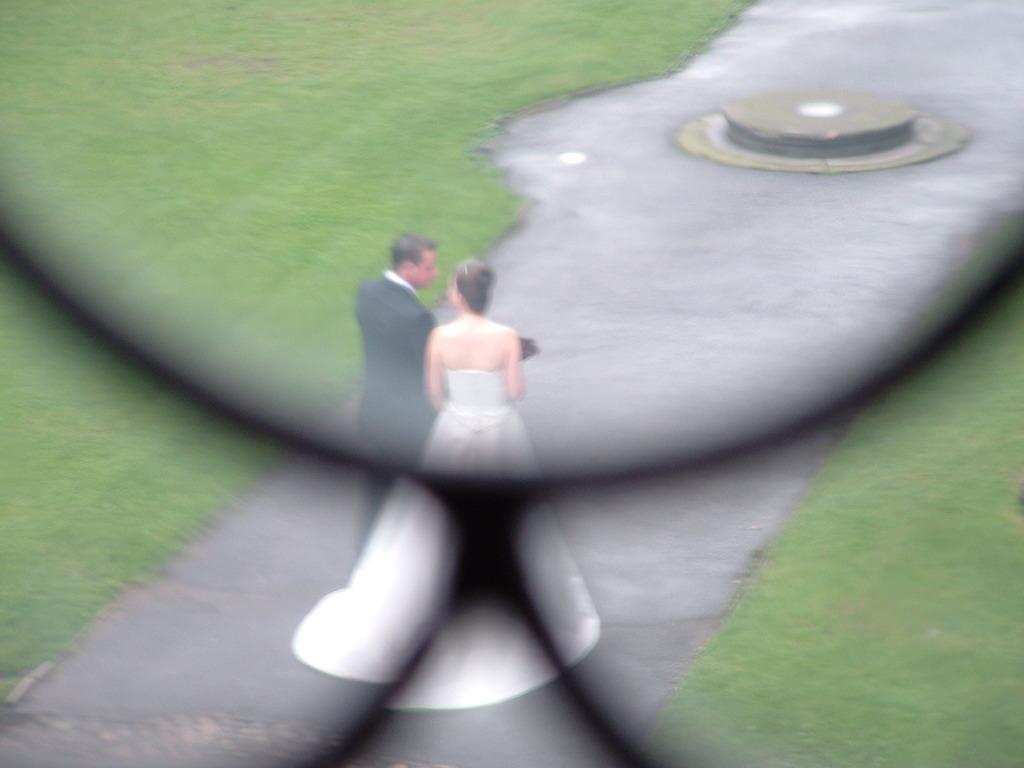Please provide a concise description of this image. In the foreground of the picture there is an object. In the center of the picture there is a couple walking on the path. On the right there is grass. On the left there is grass. At the top there is an object. 